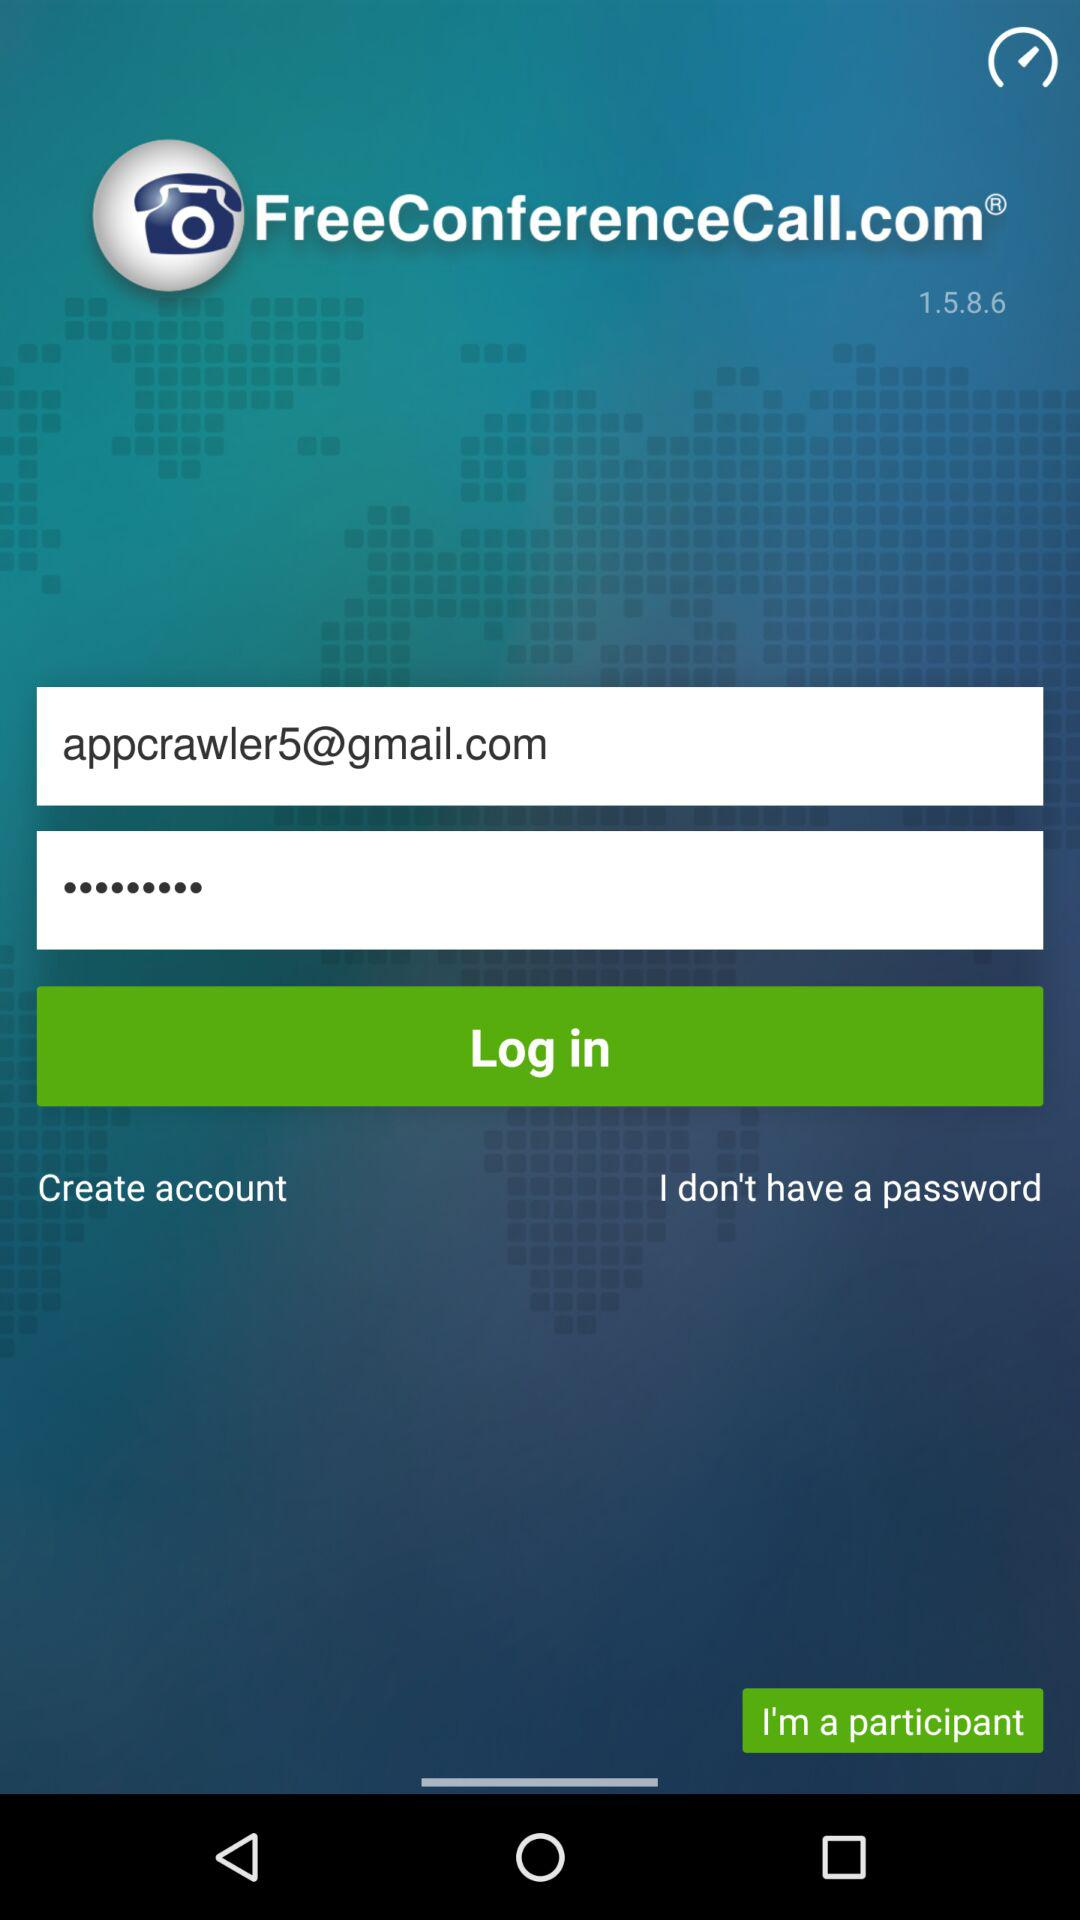What is the app title? The app title is "FreeConferenceCall.com". 